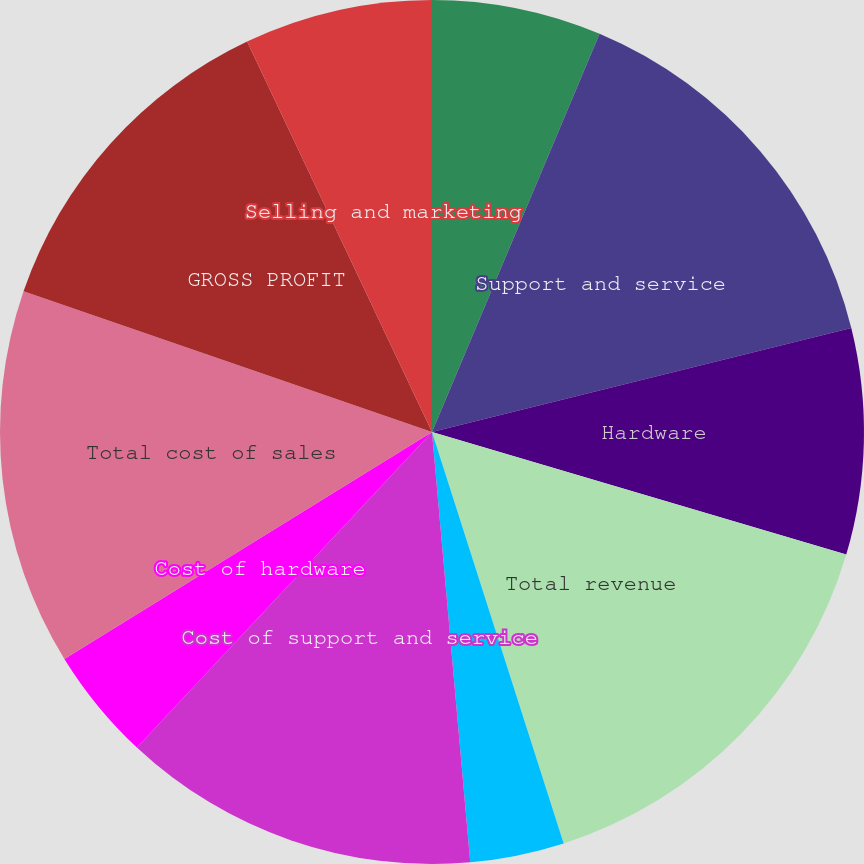Convert chart to OTSL. <chart><loc_0><loc_0><loc_500><loc_500><pie_chart><fcel>License<fcel>Support and service<fcel>Hardware<fcel>Total revenue<fcel>Cost of license<fcel>Cost of support and service<fcel>Cost of hardware<fcel>Total cost of sales<fcel>GROSS PROFIT<fcel>Selling and marketing<nl><fcel>6.34%<fcel>14.79%<fcel>8.45%<fcel>15.49%<fcel>3.52%<fcel>13.38%<fcel>4.23%<fcel>14.08%<fcel>12.68%<fcel>7.04%<nl></chart> 